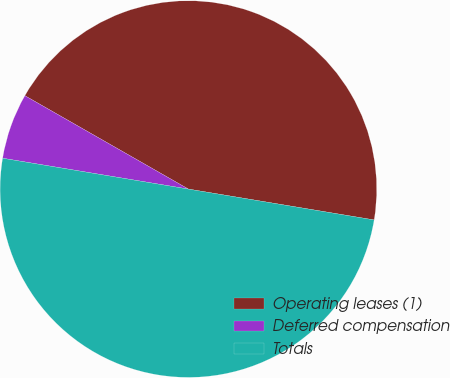Convert chart to OTSL. <chart><loc_0><loc_0><loc_500><loc_500><pie_chart><fcel>Operating leases (1)<fcel>Deferred compensation<fcel>Totals<nl><fcel>44.36%<fcel>5.64%<fcel>50.0%<nl></chart> 